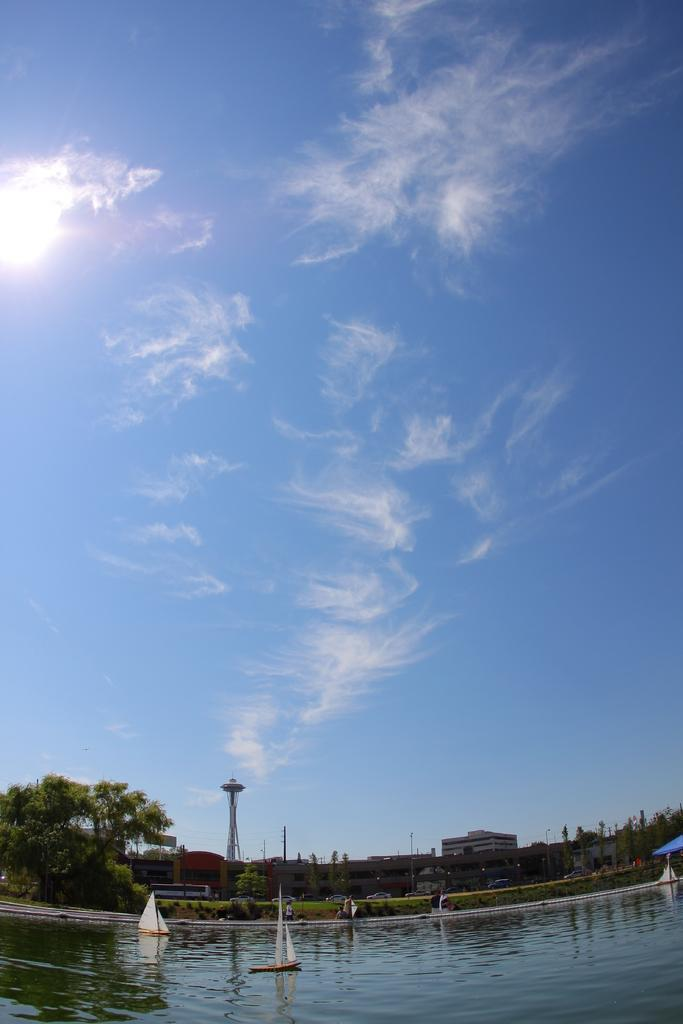What is located in the foreground of the image? There are boats in the foreground of the image. What is the location of the boats in the image? The boats are on the water. What can be seen in the background of the image? There are trees, buildings, a tower, and poles in the background of the image. What is visible in the sky in the image? The sky is visible in the background of the image, and there is a cloud in the sky. What type of art can be seen on the boats in the image? There is no art visible on the boats in the image. What is the source of power for the boats in the image? The boats in the image do not have engines, as they are likely sailboats or other non-motorized vessels. What color are the eyes of the trees in the background of the image? Trees do not have eyes, so this question cannot be answered. 